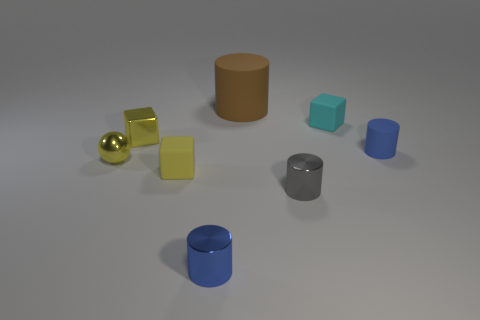Subtract 2 cylinders. How many cylinders are left? 2 Subtract all yellow metallic cubes. How many cubes are left? 2 Subtract all brown cylinders. How many yellow cubes are left? 2 Subtract all brown cylinders. How many cylinders are left? 3 Add 2 small red rubber spheres. How many objects exist? 10 Subtract all cubes. How many objects are left? 5 Subtract all green cubes. Subtract all purple balls. How many cubes are left? 3 Subtract all tiny blue shiny cylinders. Subtract all small shiny objects. How many objects are left? 3 Add 2 cyan rubber objects. How many cyan rubber objects are left? 3 Add 7 small blue cylinders. How many small blue cylinders exist? 9 